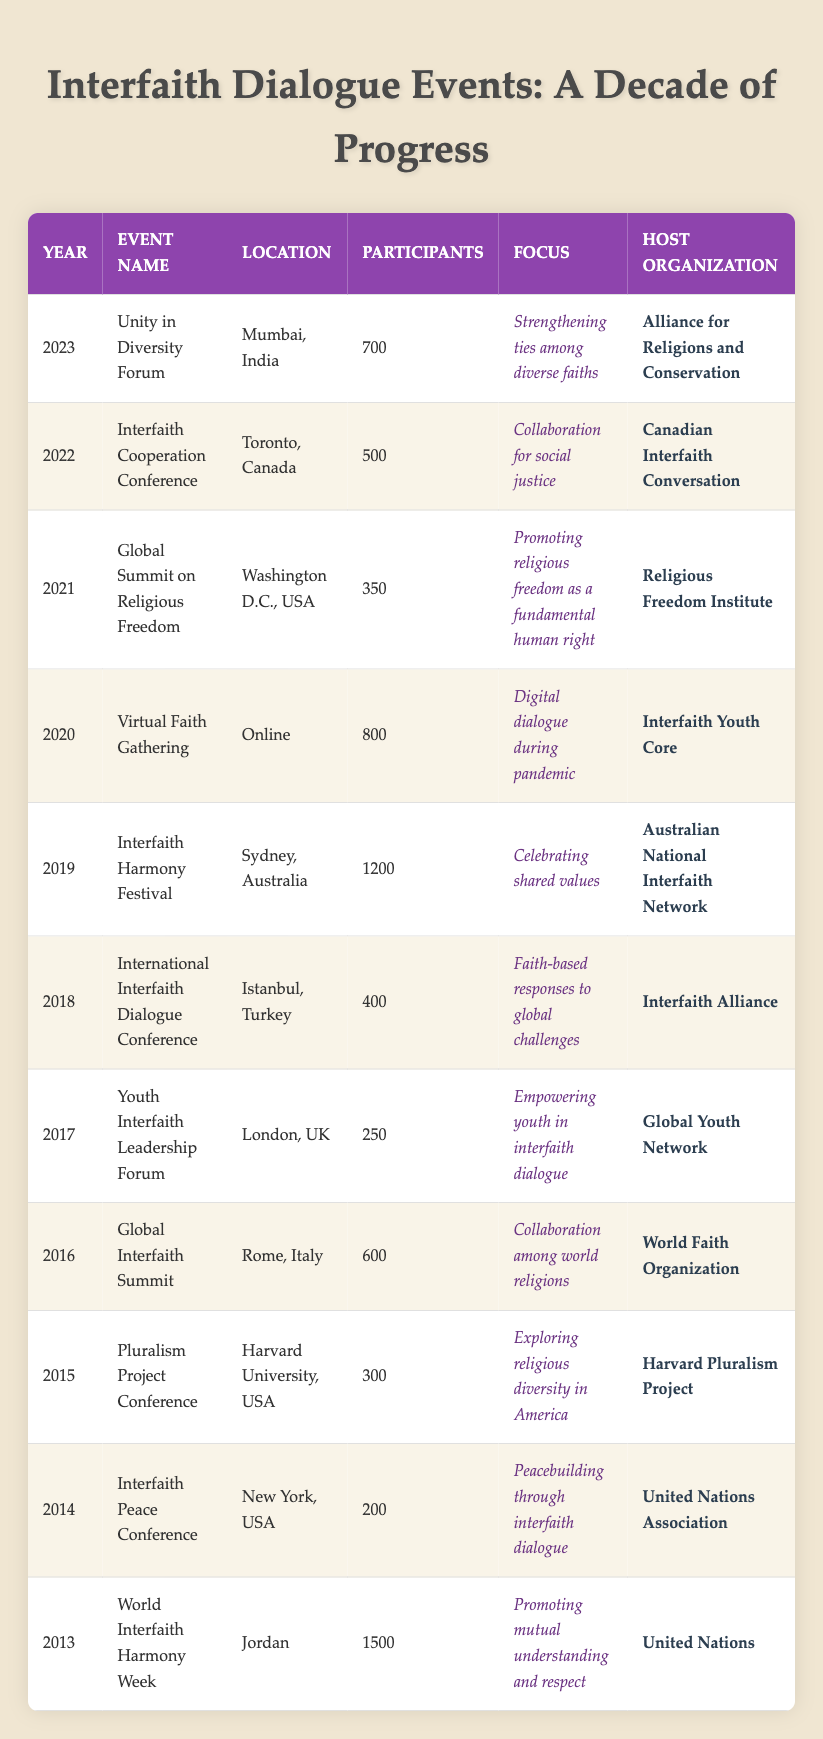What was the location of the event in 2022? The location of the event listed for 2022, which is the Interfaith Cooperation Conference, is Toronto, Canada. This can be directly retrieved from the table under the year 2022.
Answer: Toronto, Canada How many participants attended the Global Interfaith Summit? The Global Interfaith Summit took place in 2016 and had 600 participants. This information can be found in the row corresponding to the year 2016.
Answer: 600 Did the number of participants increase from the Interfaith Peace Conference in 2014 to the Unity in Diversity Forum in 2023? The Interfaith Peace Conference in 2014 had 200 participants while the Unity in Diversity Forum in 2023 had 700 participants. Since 700 is greater than 200, the number of participants did increase.
Answer: Yes What is the average number of participants for events held in North America (USA and Canada) from 2013 to 2023? The events in North America are: Interfaith Peace Conference (200 participants), Pluralism Project Conference (300 participants), Global Summit on Religious Freedom (350 participants), Interfaith Cooperation Conference (500 participants), and World Interfaith Harmony Week (1500 participants). The sum is 200 + 300 + 350 + 500 + 1500 = 2850. There are 5 events, so the average is 2850 divided by 5, which equals 570.
Answer: 570 Which event in 2019 had the highest participation, and how many participants were there? The event in 2019 is the Interfaith Harmony Festival, which had 1200 participants. This is listed as the maximum number under the participants column.
Answer: Interfaith Harmony Festival, 1200 What was the main focus of the event held in 2015? The main focus of the Pluralism Project Conference, held in 2015, was exploring religious diversity in America. This can be directly found in the description under the focus column for that year.
Answer: Exploring religious diversity in America What year had more than 1000 participants, and how many were there? The World Interfaith Harmony Week in 2013 had 1500 participants and the Interfaith Harmony Festival in 2019 had 1200 participants. Therefore, both events had more than 1000 participants, with the maximum being 1500 in 2013.
Answer: 2013, 1500 Was the Global Summit on Religious Freedom held before the Virtual Faith Gathering? The Global Summit on Religious Freedom was held in 2021 and the Virtual Faith Gathering was held in 2020. Since 2021 is after 2020, the statement is true.
Answer: No What organization hosted the event in 2018, and what was its focus? The organization hosting the International Interfaith Dialogue Conference in 2018 was the Interfaith Alliance, with the focus being on faith-based responses to global challenges. This information can be found in the respective columns for the year 2018.
Answer: Interfaith Alliance, faith-based responses to global challenges 